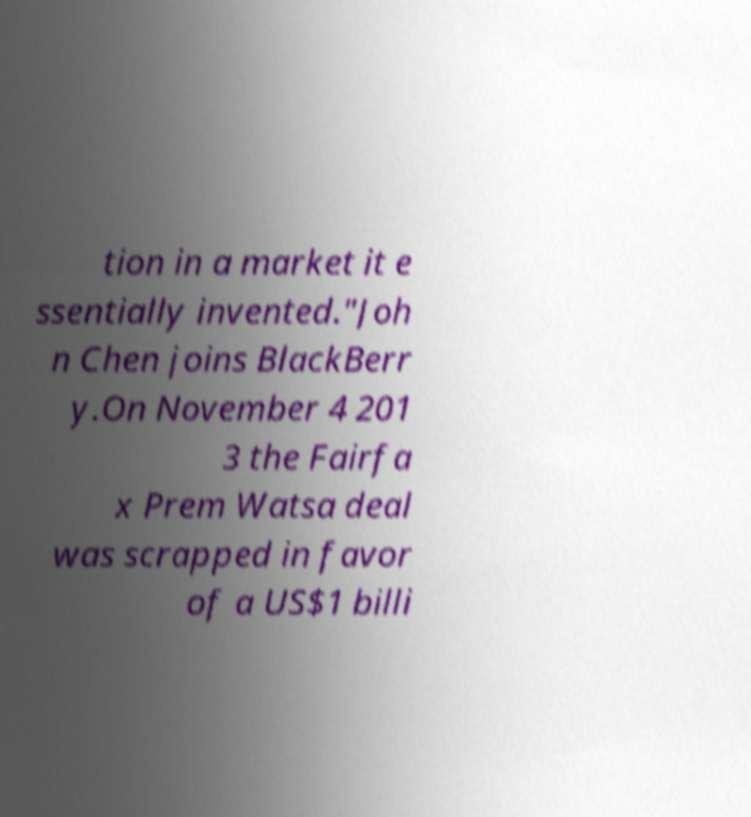Please read and relay the text visible in this image. What does it say? tion in a market it e ssentially invented."Joh n Chen joins BlackBerr y.On November 4 201 3 the Fairfa x Prem Watsa deal was scrapped in favor of a US$1 billi 